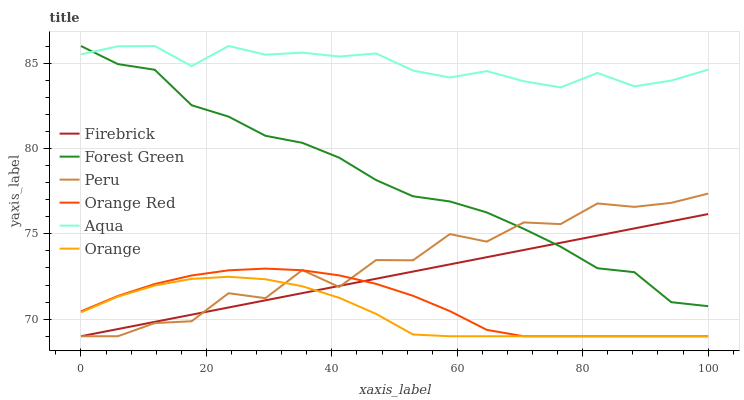Does Orange have the minimum area under the curve?
Answer yes or no. Yes. Does Aqua have the maximum area under the curve?
Answer yes or no. Yes. Does Forest Green have the minimum area under the curve?
Answer yes or no. No. Does Forest Green have the maximum area under the curve?
Answer yes or no. No. Is Firebrick the smoothest?
Answer yes or no. Yes. Is Peru the roughest?
Answer yes or no. Yes. Is Aqua the smoothest?
Answer yes or no. No. Is Aqua the roughest?
Answer yes or no. No. Does Firebrick have the lowest value?
Answer yes or no. Yes. Does Forest Green have the lowest value?
Answer yes or no. No. Does Forest Green have the highest value?
Answer yes or no. Yes. Does Peru have the highest value?
Answer yes or no. No. Is Orange less than Aqua?
Answer yes or no. Yes. Is Forest Green greater than Orange?
Answer yes or no. Yes. Does Peru intersect Orange Red?
Answer yes or no. Yes. Is Peru less than Orange Red?
Answer yes or no. No. Is Peru greater than Orange Red?
Answer yes or no. No. Does Orange intersect Aqua?
Answer yes or no. No. 